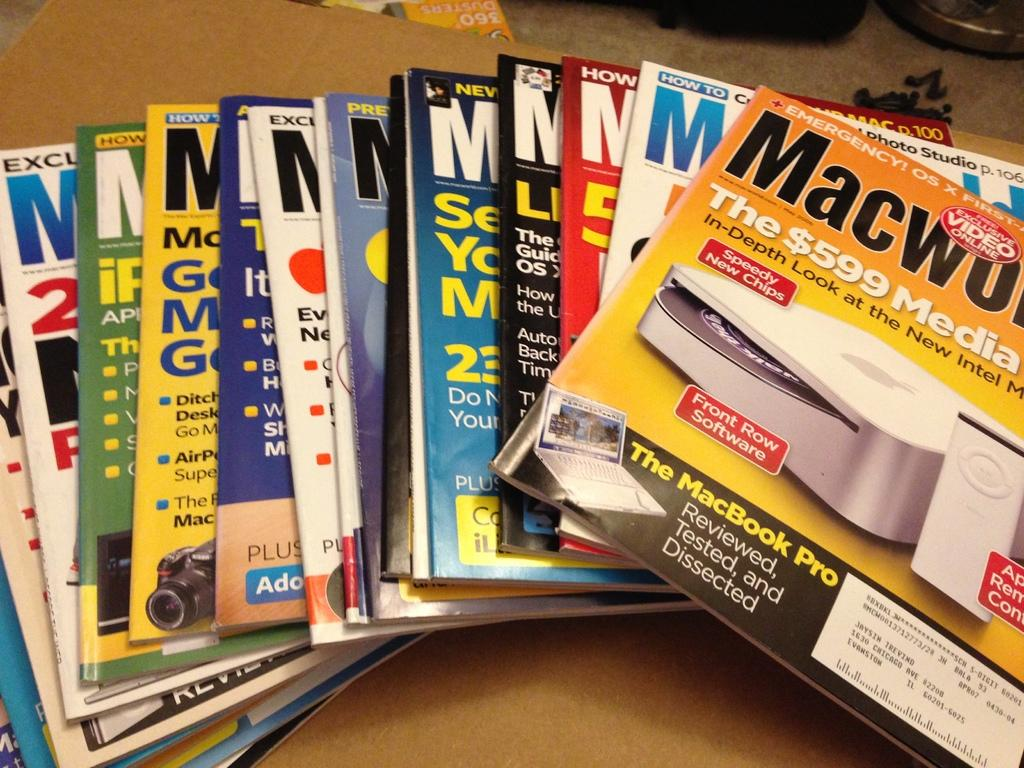Provide a one-sentence caption for the provided image. A variety of Macworld magazines are laid out on a table. 